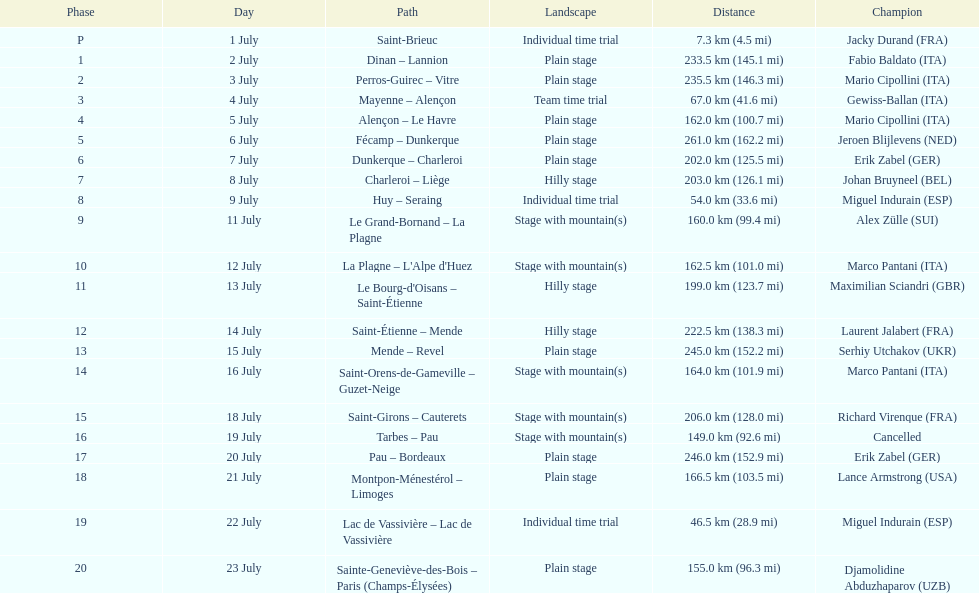How many consecutive km were raced on july 8th? 203.0 km (126.1 mi). 